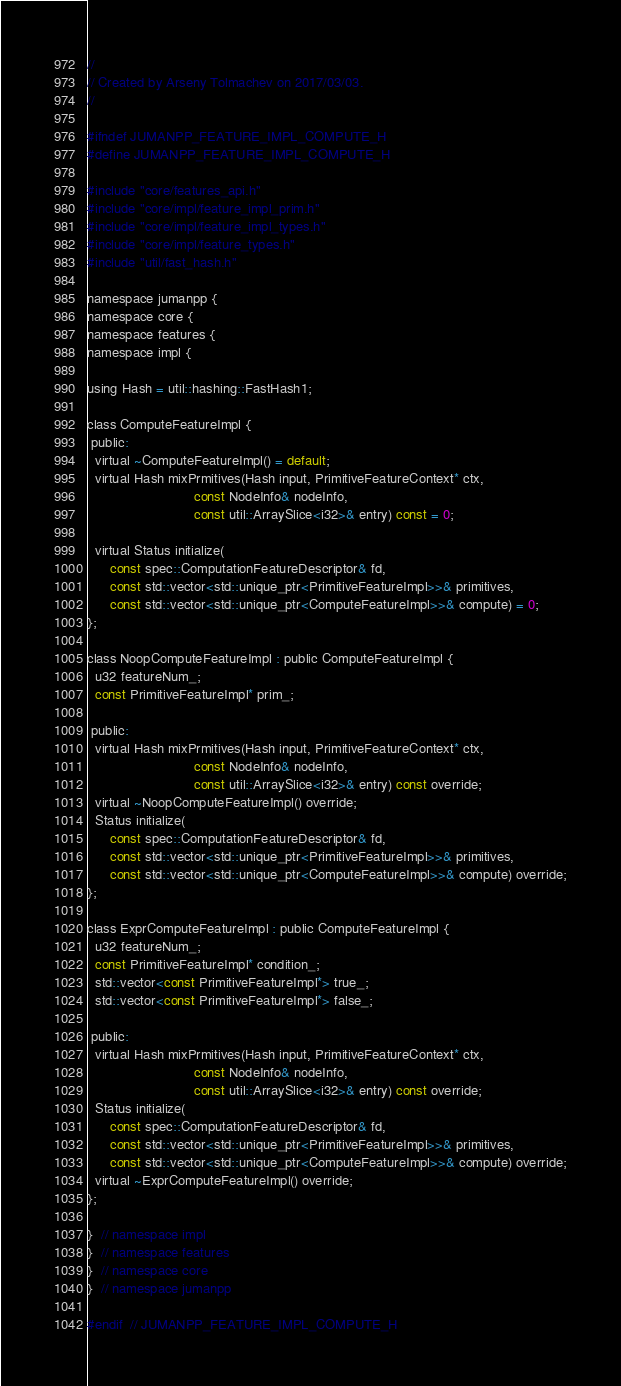Convert code to text. <code><loc_0><loc_0><loc_500><loc_500><_C_>//
// Created by Arseny Tolmachev on 2017/03/03.
//

#ifndef JUMANPP_FEATURE_IMPL_COMPUTE_H
#define JUMANPP_FEATURE_IMPL_COMPUTE_H

#include "core/features_api.h"
#include "core/impl/feature_impl_prim.h"
#include "core/impl/feature_impl_types.h"
#include "core/impl/feature_types.h"
#include "util/fast_hash.h"

namespace jumanpp {
namespace core {
namespace features {
namespace impl {

using Hash = util::hashing::FastHash1;

class ComputeFeatureImpl {
 public:
  virtual ~ComputeFeatureImpl() = default;
  virtual Hash mixPrmitives(Hash input, PrimitiveFeatureContext* ctx,
                            const NodeInfo& nodeInfo,
                            const util::ArraySlice<i32>& entry) const = 0;

  virtual Status initialize(
      const spec::ComputationFeatureDescriptor& fd,
      const std::vector<std::unique_ptr<PrimitiveFeatureImpl>>& primitives,
      const std::vector<std::unique_ptr<ComputeFeatureImpl>>& compute) = 0;
};

class NoopComputeFeatureImpl : public ComputeFeatureImpl {
  u32 featureNum_;
  const PrimitiveFeatureImpl* prim_;

 public:
  virtual Hash mixPrmitives(Hash input, PrimitiveFeatureContext* ctx,
                            const NodeInfo& nodeInfo,
                            const util::ArraySlice<i32>& entry) const override;
  virtual ~NoopComputeFeatureImpl() override;
  Status initialize(
      const spec::ComputationFeatureDescriptor& fd,
      const std::vector<std::unique_ptr<PrimitiveFeatureImpl>>& primitives,
      const std::vector<std::unique_ptr<ComputeFeatureImpl>>& compute) override;
};

class ExprComputeFeatureImpl : public ComputeFeatureImpl {
  u32 featureNum_;
  const PrimitiveFeatureImpl* condition_;
  std::vector<const PrimitiveFeatureImpl*> true_;
  std::vector<const PrimitiveFeatureImpl*> false_;

 public:
  virtual Hash mixPrmitives(Hash input, PrimitiveFeatureContext* ctx,
                            const NodeInfo& nodeInfo,
                            const util::ArraySlice<i32>& entry) const override;
  Status initialize(
      const spec::ComputationFeatureDescriptor& fd,
      const std::vector<std::unique_ptr<PrimitiveFeatureImpl>>& primitives,
      const std::vector<std::unique_ptr<ComputeFeatureImpl>>& compute) override;
  virtual ~ExprComputeFeatureImpl() override;
};

}  // namespace impl
}  // namespace features
}  // namespace core
}  // namespace jumanpp

#endif  // JUMANPP_FEATURE_IMPL_COMPUTE_H
</code> 